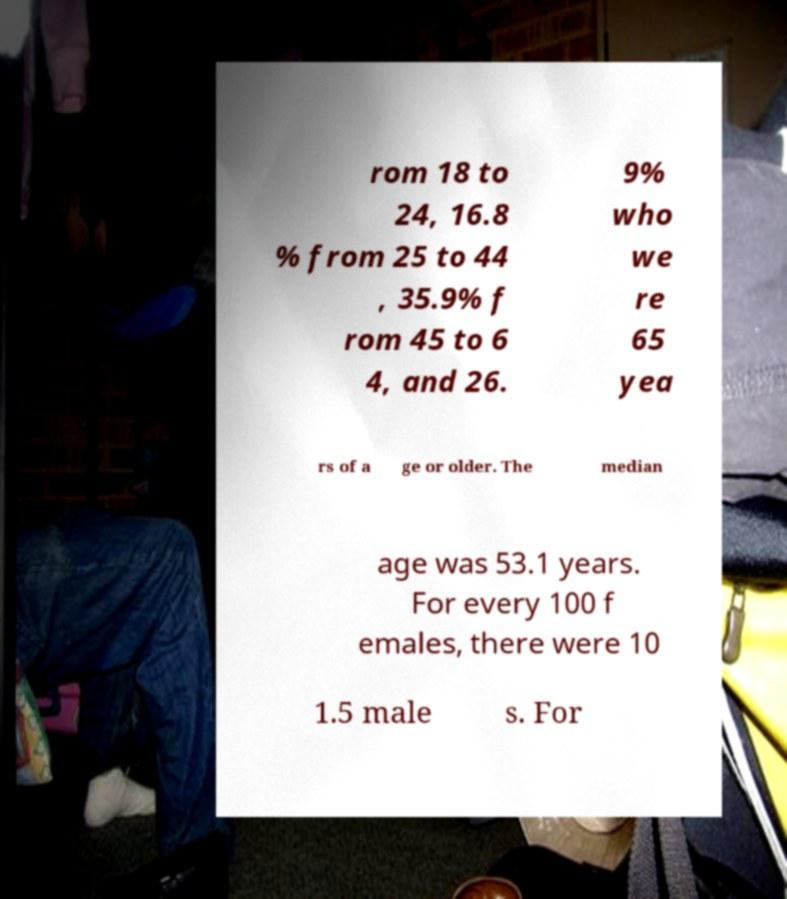Could you extract and type out the text from this image? rom 18 to 24, 16.8 % from 25 to 44 , 35.9% f rom 45 to 6 4, and 26. 9% who we re 65 yea rs of a ge or older. The median age was 53.1 years. For every 100 f emales, there were 10 1.5 male s. For 